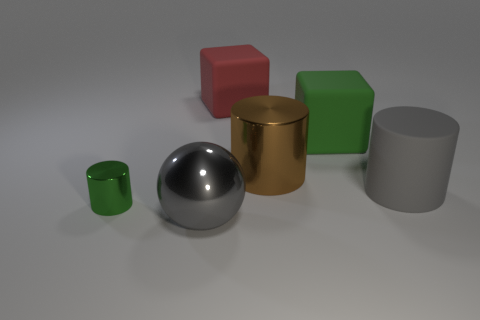There is a object that is the same color as the metallic ball; what is its shape?
Ensure brevity in your answer.  Cylinder. How many things are either large gray objects to the right of the red matte cube or big gray objects in front of the tiny green metal cylinder?
Your response must be concise. 2. Do the metallic thing that is in front of the small green metal thing and the cylinder right of the big metallic cylinder have the same color?
Keep it short and to the point. Yes. There is a thing that is behind the gray ball and in front of the big gray cylinder; what is its shape?
Ensure brevity in your answer.  Cylinder. The rubber cylinder that is the same size as the brown thing is what color?
Ensure brevity in your answer.  Gray. Are there any metallic balls of the same color as the rubber cylinder?
Your response must be concise. Yes. There is a shiny cylinder that is right of the gray metallic object; does it have the same size as the cube that is to the right of the big brown cylinder?
Keep it short and to the point. Yes. What is the thing that is behind the gray matte cylinder and right of the big metal cylinder made of?
Your answer should be very brief. Rubber. What is the size of the matte cylinder that is the same color as the ball?
Provide a succinct answer. Large. How many other objects are there of the same size as the rubber cylinder?
Offer a terse response. 4. 